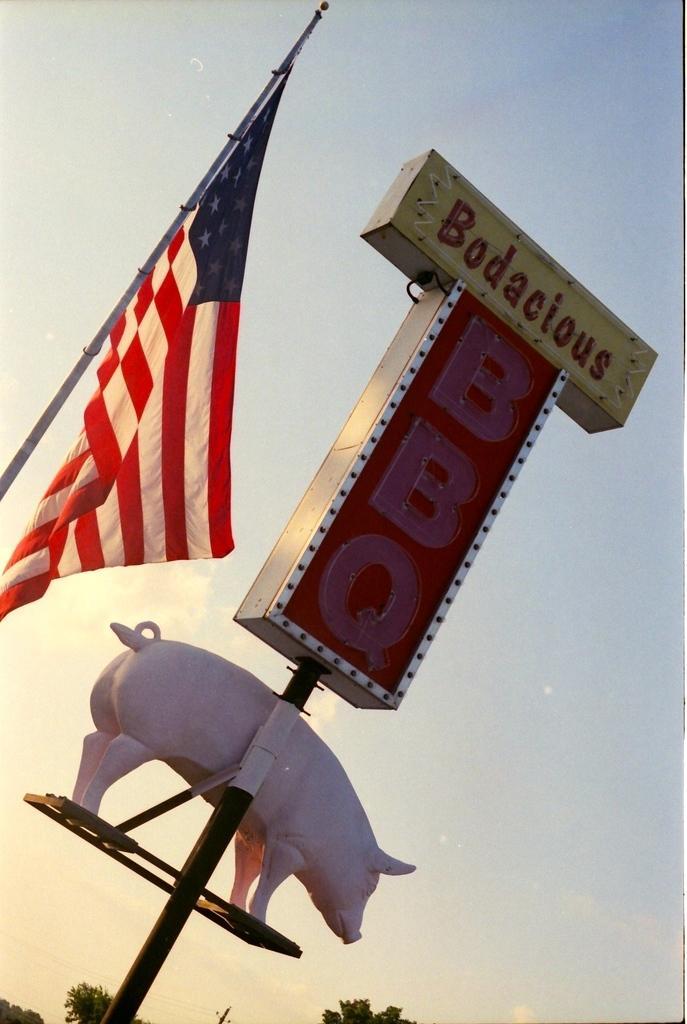Could you give a brief overview of what you see in this image? In this image I can see there is a statue of a pig and a board. At the back there are trees, flag and a sky. 